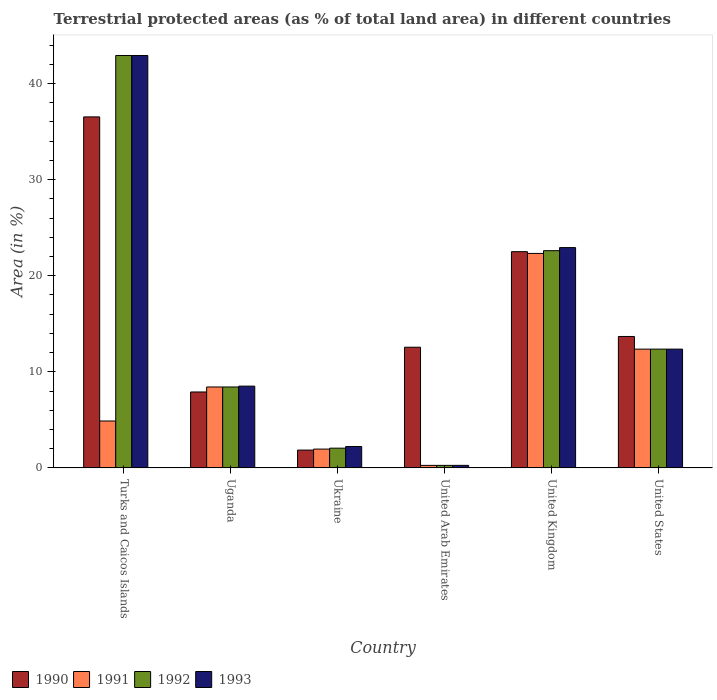How many groups of bars are there?
Your response must be concise. 6. Are the number of bars per tick equal to the number of legend labels?
Your response must be concise. Yes. How many bars are there on the 5th tick from the right?
Give a very brief answer. 4. What is the label of the 4th group of bars from the left?
Your answer should be very brief. United Arab Emirates. In how many cases, is the number of bars for a given country not equal to the number of legend labels?
Provide a succinct answer. 0. What is the percentage of terrestrial protected land in 1990 in Ukraine?
Your response must be concise. 1.86. Across all countries, what is the maximum percentage of terrestrial protected land in 1991?
Give a very brief answer. 22.32. Across all countries, what is the minimum percentage of terrestrial protected land in 1992?
Give a very brief answer. 0.27. In which country was the percentage of terrestrial protected land in 1990 maximum?
Give a very brief answer. Turks and Caicos Islands. In which country was the percentage of terrestrial protected land in 1993 minimum?
Offer a very short reply. United Arab Emirates. What is the total percentage of terrestrial protected land in 1990 in the graph?
Offer a terse response. 95.04. What is the difference between the percentage of terrestrial protected land in 1990 in Ukraine and that in United States?
Offer a terse response. -11.82. What is the difference between the percentage of terrestrial protected land in 1991 in United Arab Emirates and the percentage of terrestrial protected land in 1992 in Turks and Caicos Islands?
Offer a terse response. -42.65. What is the average percentage of terrestrial protected land in 1992 per country?
Offer a very short reply. 14.77. What is the difference between the percentage of terrestrial protected land of/in 1993 and percentage of terrestrial protected land of/in 1992 in Ukraine?
Offer a terse response. 0.17. What is the ratio of the percentage of terrestrial protected land in 1990 in Ukraine to that in United States?
Your answer should be compact. 0.14. Is the percentage of terrestrial protected land in 1993 in Turks and Caicos Islands less than that in United Arab Emirates?
Offer a terse response. No. What is the difference between the highest and the second highest percentage of terrestrial protected land in 1993?
Offer a very short reply. 30.55. What is the difference between the highest and the lowest percentage of terrestrial protected land in 1993?
Your answer should be very brief. 42.65. In how many countries, is the percentage of terrestrial protected land in 1990 greater than the average percentage of terrestrial protected land in 1990 taken over all countries?
Make the answer very short. 2. Is the sum of the percentage of terrestrial protected land in 1992 in Uganda and Ukraine greater than the maximum percentage of terrestrial protected land in 1990 across all countries?
Offer a terse response. No. What does the 4th bar from the left in Turks and Caicos Islands represents?
Provide a succinct answer. 1993. Are all the bars in the graph horizontal?
Provide a short and direct response. No. How many countries are there in the graph?
Ensure brevity in your answer.  6. Are the values on the major ticks of Y-axis written in scientific E-notation?
Your response must be concise. No. Does the graph contain grids?
Your response must be concise. No. Where does the legend appear in the graph?
Your response must be concise. Bottom left. What is the title of the graph?
Give a very brief answer. Terrestrial protected areas (as % of total land area) in different countries. Does "2015" appear as one of the legend labels in the graph?
Ensure brevity in your answer.  No. What is the label or title of the X-axis?
Give a very brief answer. Country. What is the label or title of the Y-axis?
Your response must be concise. Area (in %). What is the Area (in %) in 1990 in Turks and Caicos Islands?
Make the answer very short. 36.53. What is the Area (in %) in 1991 in Turks and Caicos Islands?
Give a very brief answer. 4.89. What is the Area (in %) of 1992 in Turks and Caicos Islands?
Provide a short and direct response. 42.92. What is the Area (in %) of 1993 in Turks and Caicos Islands?
Your answer should be very brief. 42.92. What is the Area (in %) of 1990 in Uganda?
Give a very brief answer. 7.91. What is the Area (in %) of 1991 in Uganda?
Give a very brief answer. 8.43. What is the Area (in %) of 1992 in Uganda?
Your response must be concise. 8.43. What is the Area (in %) of 1993 in Uganda?
Provide a succinct answer. 8.51. What is the Area (in %) of 1990 in Ukraine?
Your answer should be compact. 1.86. What is the Area (in %) in 1991 in Ukraine?
Your answer should be compact. 1.96. What is the Area (in %) of 1992 in Ukraine?
Your answer should be very brief. 2.06. What is the Area (in %) in 1993 in Ukraine?
Your answer should be very brief. 2.23. What is the Area (in %) of 1990 in United Arab Emirates?
Give a very brief answer. 12.56. What is the Area (in %) in 1991 in United Arab Emirates?
Provide a short and direct response. 0.27. What is the Area (in %) in 1992 in United Arab Emirates?
Offer a terse response. 0.27. What is the Area (in %) of 1993 in United Arab Emirates?
Your answer should be compact. 0.27. What is the Area (in %) in 1990 in United Kingdom?
Offer a terse response. 22.51. What is the Area (in %) of 1991 in United Kingdom?
Give a very brief answer. 22.32. What is the Area (in %) in 1992 in United Kingdom?
Give a very brief answer. 22.61. What is the Area (in %) of 1993 in United Kingdom?
Your answer should be compact. 22.93. What is the Area (in %) of 1990 in United States?
Your answer should be compact. 13.68. What is the Area (in %) in 1991 in United States?
Give a very brief answer. 12.36. What is the Area (in %) in 1992 in United States?
Your response must be concise. 12.36. What is the Area (in %) in 1993 in United States?
Make the answer very short. 12.37. Across all countries, what is the maximum Area (in %) in 1990?
Offer a terse response. 36.53. Across all countries, what is the maximum Area (in %) in 1991?
Provide a succinct answer. 22.32. Across all countries, what is the maximum Area (in %) in 1992?
Your answer should be compact. 42.92. Across all countries, what is the maximum Area (in %) of 1993?
Keep it short and to the point. 42.92. Across all countries, what is the minimum Area (in %) in 1990?
Your answer should be compact. 1.86. Across all countries, what is the minimum Area (in %) in 1991?
Ensure brevity in your answer.  0.27. Across all countries, what is the minimum Area (in %) of 1992?
Keep it short and to the point. 0.27. Across all countries, what is the minimum Area (in %) in 1993?
Ensure brevity in your answer.  0.27. What is the total Area (in %) of 1990 in the graph?
Offer a terse response. 95.04. What is the total Area (in %) of 1991 in the graph?
Your answer should be very brief. 50.23. What is the total Area (in %) of 1992 in the graph?
Provide a succinct answer. 88.64. What is the total Area (in %) in 1993 in the graph?
Give a very brief answer. 89.22. What is the difference between the Area (in %) in 1990 in Turks and Caicos Islands and that in Uganda?
Give a very brief answer. 28.62. What is the difference between the Area (in %) of 1991 in Turks and Caicos Islands and that in Uganda?
Offer a terse response. -3.54. What is the difference between the Area (in %) of 1992 in Turks and Caicos Islands and that in Uganda?
Provide a short and direct response. 34.49. What is the difference between the Area (in %) of 1993 in Turks and Caicos Islands and that in Uganda?
Your response must be concise. 34.4. What is the difference between the Area (in %) of 1990 in Turks and Caicos Islands and that in Ukraine?
Offer a terse response. 34.67. What is the difference between the Area (in %) of 1991 in Turks and Caicos Islands and that in Ukraine?
Offer a terse response. 2.92. What is the difference between the Area (in %) of 1992 in Turks and Caicos Islands and that in Ukraine?
Provide a short and direct response. 40.86. What is the difference between the Area (in %) in 1993 in Turks and Caicos Islands and that in Ukraine?
Offer a terse response. 40.69. What is the difference between the Area (in %) of 1990 in Turks and Caicos Islands and that in United Arab Emirates?
Your answer should be compact. 23.97. What is the difference between the Area (in %) of 1991 in Turks and Caicos Islands and that in United Arab Emirates?
Ensure brevity in your answer.  4.62. What is the difference between the Area (in %) in 1992 in Turks and Caicos Islands and that in United Arab Emirates?
Offer a very short reply. 42.65. What is the difference between the Area (in %) in 1993 in Turks and Caicos Islands and that in United Arab Emirates?
Ensure brevity in your answer.  42.65. What is the difference between the Area (in %) in 1990 in Turks and Caicos Islands and that in United Kingdom?
Keep it short and to the point. 14.02. What is the difference between the Area (in %) in 1991 in Turks and Caicos Islands and that in United Kingdom?
Your response must be concise. -17.44. What is the difference between the Area (in %) in 1992 in Turks and Caicos Islands and that in United Kingdom?
Ensure brevity in your answer.  20.31. What is the difference between the Area (in %) of 1993 in Turks and Caicos Islands and that in United Kingdom?
Make the answer very short. 19.99. What is the difference between the Area (in %) of 1990 in Turks and Caicos Islands and that in United States?
Your answer should be very brief. 22.85. What is the difference between the Area (in %) in 1991 in Turks and Caicos Islands and that in United States?
Give a very brief answer. -7.48. What is the difference between the Area (in %) in 1992 in Turks and Caicos Islands and that in United States?
Offer a terse response. 30.55. What is the difference between the Area (in %) of 1993 in Turks and Caicos Islands and that in United States?
Provide a short and direct response. 30.55. What is the difference between the Area (in %) of 1990 in Uganda and that in Ukraine?
Your answer should be very brief. 6.05. What is the difference between the Area (in %) in 1991 in Uganda and that in Ukraine?
Ensure brevity in your answer.  6.46. What is the difference between the Area (in %) of 1992 in Uganda and that in Ukraine?
Provide a short and direct response. 6.37. What is the difference between the Area (in %) in 1993 in Uganda and that in Ukraine?
Offer a terse response. 6.28. What is the difference between the Area (in %) of 1990 in Uganda and that in United Arab Emirates?
Give a very brief answer. -4.66. What is the difference between the Area (in %) in 1991 in Uganda and that in United Arab Emirates?
Your answer should be very brief. 8.16. What is the difference between the Area (in %) in 1992 in Uganda and that in United Arab Emirates?
Your answer should be very brief. 8.16. What is the difference between the Area (in %) in 1993 in Uganda and that in United Arab Emirates?
Provide a succinct answer. 8.25. What is the difference between the Area (in %) in 1990 in Uganda and that in United Kingdom?
Keep it short and to the point. -14.6. What is the difference between the Area (in %) of 1991 in Uganda and that in United Kingdom?
Offer a very short reply. -13.9. What is the difference between the Area (in %) of 1992 in Uganda and that in United Kingdom?
Your answer should be compact. -14.18. What is the difference between the Area (in %) of 1993 in Uganda and that in United Kingdom?
Provide a short and direct response. -14.42. What is the difference between the Area (in %) in 1990 in Uganda and that in United States?
Provide a short and direct response. -5.77. What is the difference between the Area (in %) in 1991 in Uganda and that in United States?
Make the answer very short. -3.94. What is the difference between the Area (in %) in 1992 in Uganda and that in United States?
Make the answer very short. -3.94. What is the difference between the Area (in %) of 1993 in Uganda and that in United States?
Keep it short and to the point. -3.85. What is the difference between the Area (in %) of 1990 in Ukraine and that in United Arab Emirates?
Offer a very short reply. -10.7. What is the difference between the Area (in %) of 1991 in Ukraine and that in United Arab Emirates?
Your answer should be very brief. 1.69. What is the difference between the Area (in %) in 1992 in Ukraine and that in United Arab Emirates?
Offer a very short reply. 1.79. What is the difference between the Area (in %) of 1993 in Ukraine and that in United Arab Emirates?
Keep it short and to the point. 1.96. What is the difference between the Area (in %) of 1990 in Ukraine and that in United Kingdom?
Your response must be concise. -20.65. What is the difference between the Area (in %) of 1991 in Ukraine and that in United Kingdom?
Give a very brief answer. -20.36. What is the difference between the Area (in %) in 1992 in Ukraine and that in United Kingdom?
Your answer should be very brief. -20.55. What is the difference between the Area (in %) of 1993 in Ukraine and that in United Kingdom?
Your answer should be compact. -20.7. What is the difference between the Area (in %) of 1990 in Ukraine and that in United States?
Keep it short and to the point. -11.82. What is the difference between the Area (in %) in 1991 in Ukraine and that in United States?
Offer a very short reply. -10.4. What is the difference between the Area (in %) of 1992 in Ukraine and that in United States?
Your response must be concise. -10.31. What is the difference between the Area (in %) of 1993 in Ukraine and that in United States?
Your response must be concise. -10.13. What is the difference between the Area (in %) in 1990 in United Arab Emirates and that in United Kingdom?
Your answer should be very brief. -9.94. What is the difference between the Area (in %) of 1991 in United Arab Emirates and that in United Kingdom?
Provide a succinct answer. -22.05. What is the difference between the Area (in %) of 1992 in United Arab Emirates and that in United Kingdom?
Make the answer very short. -22.34. What is the difference between the Area (in %) in 1993 in United Arab Emirates and that in United Kingdom?
Your answer should be very brief. -22.66. What is the difference between the Area (in %) in 1990 in United Arab Emirates and that in United States?
Make the answer very short. -1.12. What is the difference between the Area (in %) of 1991 in United Arab Emirates and that in United States?
Your response must be concise. -12.1. What is the difference between the Area (in %) of 1992 in United Arab Emirates and that in United States?
Give a very brief answer. -12.1. What is the difference between the Area (in %) in 1993 in United Arab Emirates and that in United States?
Your response must be concise. -12.1. What is the difference between the Area (in %) of 1990 in United Kingdom and that in United States?
Your answer should be compact. 8.83. What is the difference between the Area (in %) of 1991 in United Kingdom and that in United States?
Give a very brief answer. 9.96. What is the difference between the Area (in %) of 1992 in United Kingdom and that in United States?
Offer a terse response. 10.24. What is the difference between the Area (in %) in 1993 in United Kingdom and that in United States?
Ensure brevity in your answer.  10.56. What is the difference between the Area (in %) of 1990 in Turks and Caicos Islands and the Area (in %) of 1991 in Uganda?
Keep it short and to the point. 28.1. What is the difference between the Area (in %) of 1990 in Turks and Caicos Islands and the Area (in %) of 1992 in Uganda?
Keep it short and to the point. 28.1. What is the difference between the Area (in %) of 1990 in Turks and Caicos Islands and the Area (in %) of 1993 in Uganda?
Give a very brief answer. 28.02. What is the difference between the Area (in %) in 1991 in Turks and Caicos Islands and the Area (in %) in 1992 in Uganda?
Your answer should be compact. -3.54. What is the difference between the Area (in %) of 1991 in Turks and Caicos Islands and the Area (in %) of 1993 in Uganda?
Ensure brevity in your answer.  -3.63. What is the difference between the Area (in %) of 1992 in Turks and Caicos Islands and the Area (in %) of 1993 in Uganda?
Give a very brief answer. 34.4. What is the difference between the Area (in %) in 1990 in Turks and Caicos Islands and the Area (in %) in 1991 in Ukraine?
Offer a terse response. 34.57. What is the difference between the Area (in %) in 1990 in Turks and Caicos Islands and the Area (in %) in 1992 in Ukraine?
Your response must be concise. 34.47. What is the difference between the Area (in %) in 1990 in Turks and Caicos Islands and the Area (in %) in 1993 in Ukraine?
Ensure brevity in your answer.  34.3. What is the difference between the Area (in %) of 1991 in Turks and Caicos Islands and the Area (in %) of 1992 in Ukraine?
Give a very brief answer. 2.83. What is the difference between the Area (in %) of 1991 in Turks and Caicos Islands and the Area (in %) of 1993 in Ukraine?
Provide a succinct answer. 2.66. What is the difference between the Area (in %) in 1992 in Turks and Caicos Islands and the Area (in %) in 1993 in Ukraine?
Offer a terse response. 40.69. What is the difference between the Area (in %) in 1990 in Turks and Caicos Islands and the Area (in %) in 1991 in United Arab Emirates?
Your answer should be compact. 36.26. What is the difference between the Area (in %) of 1990 in Turks and Caicos Islands and the Area (in %) of 1992 in United Arab Emirates?
Keep it short and to the point. 36.26. What is the difference between the Area (in %) in 1990 in Turks and Caicos Islands and the Area (in %) in 1993 in United Arab Emirates?
Keep it short and to the point. 36.26. What is the difference between the Area (in %) of 1991 in Turks and Caicos Islands and the Area (in %) of 1992 in United Arab Emirates?
Provide a succinct answer. 4.62. What is the difference between the Area (in %) of 1991 in Turks and Caicos Islands and the Area (in %) of 1993 in United Arab Emirates?
Ensure brevity in your answer.  4.62. What is the difference between the Area (in %) in 1992 in Turks and Caicos Islands and the Area (in %) in 1993 in United Arab Emirates?
Make the answer very short. 42.65. What is the difference between the Area (in %) of 1990 in Turks and Caicos Islands and the Area (in %) of 1991 in United Kingdom?
Your answer should be very brief. 14.21. What is the difference between the Area (in %) of 1990 in Turks and Caicos Islands and the Area (in %) of 1992 in United Kingdom?
Offer a very short reply. 13.92. What is the difference between the Area (in %) of 1990 in Turks and Caicos Islands and the Area (in %) of 1993 in United Kingdom?
Offer a very short reply. 13.6. What is the difference between the Area (in %) of 1991 in Turks and Caicos Islands and the Area (in %) of 1992 in United Kingdom?
Provide a short and direct response. -17.72. What is the difference between the Area (in %) in 1991 in Turks and Caicos Islands and the Area (in %) in 1993 in United Kingdom?
Give a very brief answer. -18.04. What is the difference between the Area (in %) of 1992 in Turks and Caicos Islands and the Area (in %) of 1993 in United Kingdom?
Keep it short and to the point. 19.99. What is the difference between the Area (in %) in 1990 in Turks and Caicos Islands and the Area (in %) in 1991 in United States?
Keep it short and to the point. 24.17. What is the difference between the Area (in %) of 1990 in Turks and Caicos Islands and the Area (in %) of 1992 in United States?
Give a very brief answer. 24.16. What is the difference between the Area (in %) of 1990 in Turks and Caicos Islands and the Area (in %) of 1993 in United States?
Provide a short and direct response. 24.16. What is the difference between the Area (in %) of 1991 in Turks and Caicos Islands and the Area (in %) of 1992 in United States?
Offer a very short reply. -7.48. What is the difference between the Area (in %) in 1991 in Turks and Caicos Islands and the Area (in %) in 1993 in United States?
Offer a terse response. -7.48. What is the difference between the Area (in %) in 1992 in Turks and Caicos Islands and the Area (in %) in 1993 in United States?
Provide a succinct answer. 30.55. What is the difference between the Area (in %) of 1990 in Uganda and the Area (in %) of 1991 in Ukraine?
Offer a terse response. 5.94. What is the difference between the Area (in %) in 1990 in Uganda and the Area (in %) in 1992 in Ukraine?
Give a very brief answer. 5.85. What is the difference between the Area (in %) in 1990 in Uganda and the Area (in %) in 1993 in Ukraine?
Your answer should be very brief. 5.68. What is the difference between the Area (in %) of 1991 in Uganda and the Area (in %) of 1992 in Ukraine?
Offer a very short reply. 6.37. What is the difference between the Area (in %) of 1991 in Uganda and the Area (in %) of 1993 in Ukraine?
Ensure brevity in your answer.  6.19. What is the difference between the Area (in %) in 1992 in Uganda and the Area (in %) in 1993 in Ukraine?
Provide a short and direct response. 6.19. What is the difference between the Area (in %) in 1990 in Uganda and the Area (in %) in 1991 in United Arab Emirates?
Your response must be concise. 7.64. What is the difference between the Area (in %) of 1990 in Uganda and the Area (in %) of 1992 in United Arab Emirates?
Ensure brevity in your answer.  7.64. What is the difference between the Area (in %) in 1990 in Uganda and the Area (in %) in 1993 in United Arab Emirates?
Offer a very short reply. 7.64. What is the difference between the Area (in %) in 1991 in Uganda and the Area (in %) in 1992 in United Arab Emirates?
Give a very brief answer. 8.16. What is the difference between the Area (in %) in 1991 in Uganda and the Area (in %) in 1993 in United Arab Emirates?
Your response must be concise. 8.16. What is the difference between the Area (in %) of 1992 in Uganda and the Area (in %) of 1993 in United Arab Emirates?
Provide a succinct answer. 8.16. What is the difference between the Area (in %) in 1990 in Uganda and the Area (in %) in 1991 in United Kingdom?
Offer a terse response. -14.42. What is the difference between the Area (in %) in 1990 in Uganda and the Area (in %) in 1992 in United Kingdom?
Provide a succinct answer. -14.7. What is the difference between the Area (in %) in 1990 in Uganda and the Area (in %) in 1993 in United Kingdom?
Ensure brevity in your answer.  -15.02. What is the difference between the Area (in %) of 1991 in Uganda and the Area (in %) of 1992 in United Kingdom?
Your response must be concise. -14.18. What is the difference between the Area (in %) of 1991 in Uganda and the Area (in %) of 1993 in United Kingdom?
Offer a very short reply. -14.5. What is the difference between the Area (in %) in 1992 in Uganda and the Area (in %) in 1993 in United Kingdom?
Provide a short and direct response. -14.5. What is the difference between the Area (in %) in 1990 in Uganda and the Area (in %) in 1991 in United States?
Your answer should be very brief. -4.46. What is the difference between the Area (in %) in 1990 in Uganda and the Area (in %) in 1992 in United States?
Your response must be concise. -4.46. What is the difference between the Area (in %) of 1990 in Uganda and the Area (in %) of 1993 in United States?
Your answer should be very brief. -4.46. What is the difference between the Area (in %) of 1991 in Uganda and the Area (in %) of 1992 in United States?
Offer a terse response. -3.94. What is the difference between the Area (in %) of 1991 in Uganda and the Area (in %) of 1993 in United States?
Keep it short and to the point. -3.94. What is the difference between the Area (in %) in 1992 in Uganda and the Area (in %) in 1993 in United States?
Provide a succinct answer. -3.94. What is the difference between the Area (in %) of 1990 in Ukraine and the Area (in %) of 1991 in United Arab Emirates?
Provide a succinct answer. 1.59. What is the difference between the Area (in %) of 1990 in Ukraine and the Area (in %) of 1992 in United Arab Emirates?
Offer a terse response. 1.59. What is the difference between the Area (in %) of 1990 in Ukraine and the Area (in %) of 1993 in United Arab Emirates?
Keep it short and to the point. 1.59. What is the difference between the Area (in %) in 1991 in Ukraine and the Area (in %) in 1992 in United Arab Emirates?
Provide a short and direct response. 1.69. What is the difference between the Area (in %) in 1991 in Ukraine and the Area (in %) in 1993 in United Arab Emirates?
Make the answer very short. 1.69. What is the difference between the Area (in %) in 1992 in Ukraine and the Area (in %) in 1993 in United Arab Emirates?
Your response must be concise. 1.79. What is the difference between the Area (in %) in 1990 in Ukraine and the Area (in %) in 1991 in United Kingdom?
Give a very brief answer. -20.46. What is the difference between the Area (in %) of 1990 in Ukraine and the Area (in %) of 1992 in United Kingdom?
Offer a terse response. -20.75. What is the difference between the Area (in %) in 1990 in Ukraine and the Area (in %) in 1993 in United Kingdom?
Offer a terse response. -21.07. What is the difference between the Area (in %) in 1991 in Ukraine and the Area (in %) in 1992 in United Kingdom?
Offer a very short reply. -20.65. What is the difference between the Area (in %) of 1991 in Ukraine and the Area (in %) of 1993 in United Kingdom?
Offer a terse response. -20.97. What is the difference between the Area (in %) of 1992 in Ukraine and the Area (in %) of 1993 in United Kingdom?
Provide a succinct answer. -20.87. What is the difference between the Area (in %) in 1990 in Ukraine and the Area (in %) in 1991 in United States?
Give a very brief answer. -10.5. What is the difference between the Area (in %) in 1990 in Ukraine and the Area (in %) in 1992 in United States?
Your response must be concise. -10.51. What is the difference between the Area (in %) in 1990 in Ukraine and the Area (in %) in 1993 in United States?
Make the answer very short. -10.51. What is the difference between the Area (in %) of 1991 in Ukraine and the Area (in %) of 1992 in United States?
Offer a very short reply. -10.4. What is the difference between the Area (in %) of 1991 in Ukraine and the Area (in %) of 1993 in United States?
Your answer should be very brief. -10.4. What is the difference between the Area (in %) in 1992 in Ukraine and the Area (in %) in 1993 in United States?
Offer a very short reply. -10.31. What is the difference between the Area (in %) of 1990 in United Arab Emirates and the Area (in %) of 1991 in United Kingdom?
Your answer should be compact. -9.76. What is the difference between the Area (in %) of 1990 in United Arab Emirates and the Area (in %) of 1992 in United Kingdom?
Your answer should be compact. -10.05. What is the difference between the Area (in %) in 1990 in United Arab Emirates and the Area (in %) in 1993 in United Kingdom?
Give a very brief answer. -10.37. What is the difference between the Area (in %) of 1991 in United Arab Emirates and the Area (in %) of 1992 in United Kingdom?
Provide a short and direct response. -22.34. What is the difference between the Area (in %) of 1991 in United Arab Emirates and the Area (in %) of 1993 in United Kingdom?
Offer a terse response. -22.66. What is the difference between the Area (in %) in 1992 in United Arab Emirates and the Area (in %) in 1993 in United Kingdom?
Your answer should be compact. -22.66. What is the difference between the Area (in %) in 1990 in United Arab Emirates and the Area (in %) in 1991 in United States?
Your answer should be compact. 0.2. What is the difference between the Area (in %) of 1990 in United Arab Emirates and the Area (in %) of 1992 in United States?
Ensure brevity in your answer.  0.2. What is the difference between the Area (in %) in 1990 in United Arab Emirates and the Area (in %) in 1993 in United States?
Ensure brevity in your answer.  0.2. What is the difference between the Area (in %) in 1991 in United Arab Emirates and the Area (in %) in 1992 in United States?
Ensure brevity in your answer.  -12.1. What is the difference between the Area (in %) of 1991 in United Arab Emirates and the Area (in %) of 1993 in United States?
Offer a terse response. -12.1. What is the difference between the Area (in %) of 1992 in United Arab Emirates and the Area (in %) of 1993 in United States?
Provide a short and direct response. -12.1. What is the difference between the Area (in %) of 1990 in United Kingdom and the Area (in %) of 1991 in United States?
Offer a terse response. 10.14. What is the difference between the Area (in %) in 1990 in United Kingdom and the Area (in %) in 1992 in United States?
Keep it short and to the point. 10.14. What is the difference between the Area (in %) of 1990 in United Kingdom and the Area (in %) of 1993 in United States?
Keep it short and to the point. 10.14. What is the difference between the Area (in %) in 1991 in United Kingdom and the Area (in %) in 1992 in United States?
Your response must be concise. 9.96. What is the difference between the Area (in %) of 1991 in United Kingdom and the Area (in %) of 1993 in United States?
Offer a very short reply. 9.96. What is the difference between the Area (in %) in 1992 in United Kingdom and the Area (in %) in 1993 in United States?
Provide a succinct answer. 10.24. What is the average Area (in %) of 1990 per country?
Keep it short and to the point. 15.84. What is the average Area (in %) in 1991 per country?
Provide a short and direct response. 8.37. What is the average Area (in %) in 1992 per country?
Your answer should be very brief. 14.77. What is the average Area (in %) of 1993 per country?
Provide a succinct answer. 14.87. What is the difference between the Area (in %) of 1990 and Area (in %) of 1991 in Turks and Caicos Islands?
Provide a succinct answer. 31.64. What is the difference between the Area (in %) in 1990 and Area (in %) in 1992 in Turks and Caicos Islands?
Provide a succinct answer. -6.39. What is the difference between the Area (in %) of 1990 and Area (in %) of 1993 in Turks and Caicos Islands?
Your answer should be compact. -6.39. What is the difference between the Area (in %) of 1991 and Area (in %) of 1992 in Turks and Caicos Islands?
Your answer should be very brief. -38.03. What is the difference between the Area (in %) in 1991 and Area (in %) in 1993 in Turks and Caicos Islands?
Your answer should be very brief. -38.03. What is the difference between the Area (in %) of 1990 and Area (in %) of 1991 in Uganda?
Your response must be concise. -0.52. What is the difference between the Area (in %) in 1990 and Area (in %) in 1992 in Uganda?
Your answer should be compact. -0.52. What is the difference between the Area (in %) in 1990 and Area (in %) in 1993 in Uganda?
Provide a succinct answer. -0.61. What is the difference between the Area (in %) of 1991 and Area (in %) of 1992 in Uganda?
Keep it short and to the point. 0. What is the difference between the Area (in %) of 1991 and Area (in %) of 1993 in Uganda?
Provide a short and direct response. -0.09. What is the difference between the Area (in %) of 1992 and Area (in %) of 1993 in Uganda?
Give a very brief answer. -0.09. What is the difference between the Area (in %) in 1990 and Area (in %) in 1991 in Ukraine?
Offer a terse response. -0.1. What is the difference between the Area (in %) in 1990 and Area (in %) in 1992 in Ukraine?
Provide a short and direct response. -0.2. What is the difference between the Area (in %) in 1990 and Area (in %) in 1993 in Ukraine?
Your response must be concise. -0.37. What is the difference between the Area (in %) of 1991 and Area (in %) of 1992 in Ukraine?
Provide a succinct answer. -0.1. What is the difference between the Area (in %) of 1991 and Area (in %) of 1993 in Ukraine?
Offer a very short reply. -0.27. What is the difference between the Area (in %) in 1992 and Area (in %) in 1993 in Ukraine?
Give a very brief answer. -0.17. What is the difference between the Area (in %) in 1990 and Area (in %) in 1991 in United Arab Emirates?
Your answer should be compact. 12.3. What is the difference between the Area (in %) in 1990 and Area (in %) in 1992 in United Arab Emirates?
Give a very brief answer. 12.3. What is the difference between the Area (in %) of 1990 and Area (in %) of 1993 in United Arab Emirates?
Provide a succinct answer. 12.29. What is the difference between the Area (in %) in 1991 and Area (in %) in 1993 in United Arab Emirates?
Give a very brief answer. -0. What is the difference between the Area (in %) of 1992 and Area (in %) of 1993 in United Arab Emirates?
Ensure brevity in your answer.  -0. What is the difference between the Area (in %) in 1990 and Area (in %) in 1991 in United Kingdom?
Provide a short and direct response. 0.18. What is the difference between the Area (in %) of 1990 and Area (in %) of 1992 in United Kingdom?
Your answer should be very brief. -0.1. What is the difference between the Area (in %) in 1990 and Area (in %) in 1993 in United Kingdom?
Your response must be concise. -0.42. What is the difference between the Area (in %) in 1991 and Area (in %) in 1992 in United Kingdom?
Your answer should be compact. -0.29. What is the difference between the Area (in %) in 1991 and Area (in %) in 1993 in United Kingdom?
Give a very brief answer. -0.61. What is the difference between the Area (in %) in 1992 and Area (in %) in 1993 in United Kingdom?
Offer a very short reply. -0.32. What is the difference between the Area (in %) in 1990 and Area (in %) in 1991 in United States?
Provide a short and direct response. 1.32. What is the difference between the Area (in %) in 1990 and Area (in %) in 1992 in United States?
Keep it short and to the point. 1.32. What is the difference between the Area (in %) in 1990 and Area (in %) in 1993 in United States?
Keep it short and to the point. 1.31. What is the difference between the Area (in %) of 1991 and Area (in %) of 1992 in United States?
Provide a succinct answer. -0. What is the difference between the Area (in %) of 1991 and Area (in %) of 1993 in United States?
Give a very brief answer. -0. What is the difference between the Area (in %) in 1992 and Area (in %) in 1993 in United States?
Keep it short and to the point. -0. What is the ratio of the Area (in %) of 1990 in Turks and Caicos Islands to that in Uganda?
Provide a succinct answer. 4.62. What is the ratio of the Area (in %) of 1991 in Turks and Caicos Islands to that in Uganda?
Keep it short and to the point. 0.58. What is the ratio of the Area (in %) of 1992 in Turks and Caicos Islands to that in Uganda?
Offer a very short reply. 5.09. What is the ratio of the Area (in %) in 1993 in Turks and Caicos Islands to that in Uganda?
Keep it short and to the point. 5.04. What is the ratio of the Area (in %) in 1990 in Turks and Caicos Islands to that in Ukraine?
Your response must be concise. 19.65. What is the ratio of the Area (in %) of 1991 in Turks and Caicos Islands to that in Ukraine?
Give a very brief answer. 2.49. What is the ratio of the Area (in %) of 1992 in Turks and Caicos Islands to that in Ukraine?
Offer a terse response. 20.86. What is the ratio of the Area (in %) in 1993 in Turks and Caicos Islands to that in Ukraine?
Offer a very short reply. 19.24. What is the ratio of the Area (in %) of 1990 in Turks and Caicos Islands to that in United Arab Emirates?
Offer a terse response. 2.91. What is the ratio of the Area (in %) of 1991 in Turks and Caicos Islands to that in United Arab Emirates?
Make the answer very short. 18.31. What is the ratio of the Area (in %) in 1992 in Turks and Caicos Islands to that in United Arab Emirates?
Keep it short and to the point. 160.81. What is the ratio of the Area (in %) of 1993 in Turks and Caicos Islands to that in United Arab Emirates?
Provide a succinct answer. 160.37. What is the ratio of the Area (in %) of 1990 in Turks and Caicos Islands to that in United Kingdom?
Keep it short and to the point. 1.62. What is the ratio of the Area (in %) in 1991 in Turks and Caicos Islands to that in United Kingdom?
Give a very brief answer. 0.22. What is the ratio of the Area (in %) in 1992 in Turks and Caicos Islands to that in United Kingdom?
Provide a succinct answer. 1.9. What is the ratio of the Area (in %) in 1993 in Turks and Caicos Islands to that in United Kingdom?
Keep it short and to the point. 1.87. What is the ratio of the Area (in %) of 1990 in Turks and Caicos Islands to that in United States?
Make the answer very short. 2.67. What is the ratio of the Area (in %) of 1991 in Turks and Caicos Islands to that in United States?
Ensure brevity in your answer.  0.4. What is the ratio of the Area (in %) in 1992 in Turks and Caicos Islands to that in United States?
Provide a short and direct response. 3.47. What is the ratio of the Area (in %) of 1993 in Turks and Caicos Islands to that in United States?
Give a very brief answer. 3.47. What is the ratio of the Area (in %) in 1990 in Uganda to that in Ukraine?
Give a very brief answer. 4.25. What is the ratio of the Area (in %) in 1991 in Uganda to that in Ukraine?
Keep it short and to the point. 4.29. What is the ratio of the Area (in %) of 1992 in Uganda to that in Ukraine?
Ensure brevity in your answer.  4.09. What is the ratio of the Area (in %) in 1993 in Uganda to that in Ukraine?
Ensure brevity in your answer.  3.82. What is the ratio of the Area (in %) in 1990 in Uganda to that in United Arab Emirates?
Your response must be concise. 0.63. What is the ratio of the Area (in %) of 1991 in Uganda to that in United Arab Emirates?
Offer a terse response. 31.57. What is the ratio of the Area (in %) of 1992 in Uganda to that in United Arab Emirates?
Make the answer very short. 31.57. What is the ratio of the Area (in %) in 1993 in Uganda to that in United Arab Emirates?
Your response must be concise. 31.81. What is the ratio of the Area (in %) in 1990 in Uganda to that in United Kingdom?
Keep it short and to the point. 0.35. What is the ratio of the Area (in %) in 1991 in Uganda to that in United Kingdom?
Give a very brief answer. 0.38. What is the ratio of the Area (in %) in 1992 in Uganda to that in United Kingdom?
Your answer should be compact. 0.37. What is the ratio of the Area (in %) in 1993 in Uganda to that in United Kingdom?
Give a very brief answer. 0.37. What is the ratio of the Area (in %) in 1990 in Uganda to that in United States?
Provide a short and direct response. 0.58. What is the ratio of the Area (in %) in 1991 in Uganda to that in United States?
Your answer should be very brief. 0.68. What is the ratio of the Area (in %) of 1992 in Uganda to that in United States?
Provide a succinct answer. 0.68. What is the ratio of the Area (in %) of 1993 in Uganda to that in United States?
Your answer should be compact. 0.69. What is the ratio of the Area (in %) in 1990 in Ukraine to that in United Arab Emirates?
Provide a succinct answer. 0.15. What is the ratio of the Area (in %) in 1991 in Ukraine to that in United Arab Emirates?
Provide a short and direct response. 7.35. What is the ratio of the Area (in %) of 1992 in Ukraine to that in United Arab Emirates?
Keep it short and to the point. 7.71. What is the ratio of the Area (in %) of 1993 in Ukraine to that in United Arab Emirates?
Keep it short and to the point. 8.33. What is the ratio of the Area (in %) of 1990 in Ukraine to that in United Kingdom?
Ensure brevity in your answer.  0.08. What is the ratio of the Area (in %) of 1991 in Ukraine to that in United Kingdom?
Ensure brevity in your answer.  0.09. What is the ratio of the Area (in %) in 1992 in Ukraine to that in United Kingdom?
Provide a short and direct response. 0.09. What is the ratio of the Area (in %) in 1993 in Ukraine to that in United Kingdom?
Offer a terse response. 0.1. What is the ratio of the Area (in %) of 1990 in Ukraine to that in United States?
Provide a short and direct response. 0.14. What is the ratio of the Area (in %) of 1991 in Ukraine to that in United States?
Offer a terse response. 0.16. What is the ratio of the Area (in %) in 1992 in Ukraine to that in United States?
Provide a succinct answer. 0.17. What is the ratio of the Area (in %) in 1993 in Ukraine to that in United States?
Your answer should be very brief. 0.18. What is the ratio of the Area (in %) in 1990 in United Arab Emirates to that in United Kingdom?
Make the answer very short. 0.56. What is the ratio of the Area (in %) in 1991 in United Arab Emirates to that in United Kingdom?
Provide a succinct answer. 0.01. What is the ratio of the Area (in %) of 1992 in United Arab Emirates to that in United Kingdom?
Your answer should be very brief. 0.01. What is the ratio of the Area (in %) in 1993 in United Arab Emirates to that in United Kingdom?
Your answer should be compact. 0.01. What is the ratio of the Area (in %) of 1990 in United Arab Emirates to that in United States?
Your response must be concise. 0.92. What is the ratio of the Area (in %) of 1991 in United Arab Emirates to that in United States?
Offer a terse response. 0.02. What is the ratio of the Area (in %) of 1992 in United Arab Emirates to that in United States?
Your answer should be very brief. 0.02. What is the ratio of the Area (in %) of 1993 in United Arab Emirates to that in United States?
Make the answer very short. 0.02. What is the ratio of the Area (in %) of 1990 in United Kingdom to that in United States?
Ensure brevity in your answer.  1.65. What is the ratio of the Area (in %) in 1991 in United Kingdom to that in United States?
Your response must be concise. 1.81. What is the ratio of the Area (in %) of 1992 in United Kingdom to that in United States?
Provide a succinct answer. 1.83. What is the ratio of the Area (in %) of 1993 in United Kingdom to that in United States?
Provide a succinct answer. 1.85. What is the difference between the highest and the second highest Area (in %) of 1990?
Offer a very short reply. 14.02. What is the difference between the highest and the second highest Area (in %) in 1991?
Keep it short and to the point. 9.96. What is the difference between the highest and the second highest Area (in %) of 1992?
Give a very brief answer. 20.31. What is the difference between the highest and the second highest Area (in %) in 1993?
Your answer should be very brief. 19.99. What is the difference between the highest and the lowest Area (in %) of 1990?
Give a very brief answer. 34.67. What is the difference between the highest and the lowest Area (in %) of 1991?
Give a very brief answer. 22.05. What is the difference between the highest and the lowest Area (in %) of 1992?
Offer a terse response. 42.65. What is the difference between the highest and the lowest Area (in %) in 1993?
Provide a short and direct response. 42.65. 